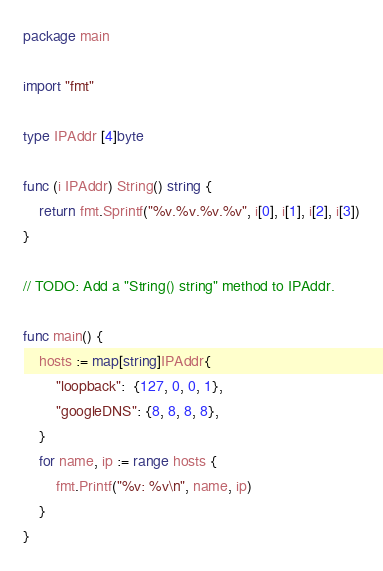<code> <loc_0><loc_0><loc_500><loc_500><_Go_>package main

import "fmt"

type IPAddr [4]byte

func (i IPAddr) String() string {
	return fmt.Sprintf("%v.%v.%v.%v", i[0], i[1], i[2], i[3])
}

// TODO: Add a "String() string" method to IPAddr.

func main() {
	hosts := map[string]IPAddr{
		"loopback":  {127, 0, 0, 1},
		"googleDNS": {8, 8, 8, 8},
	}
	for name, ip := range hosts {
		fmt.Printf("%v: %v\n", name, ip)
	}
}
</code> 